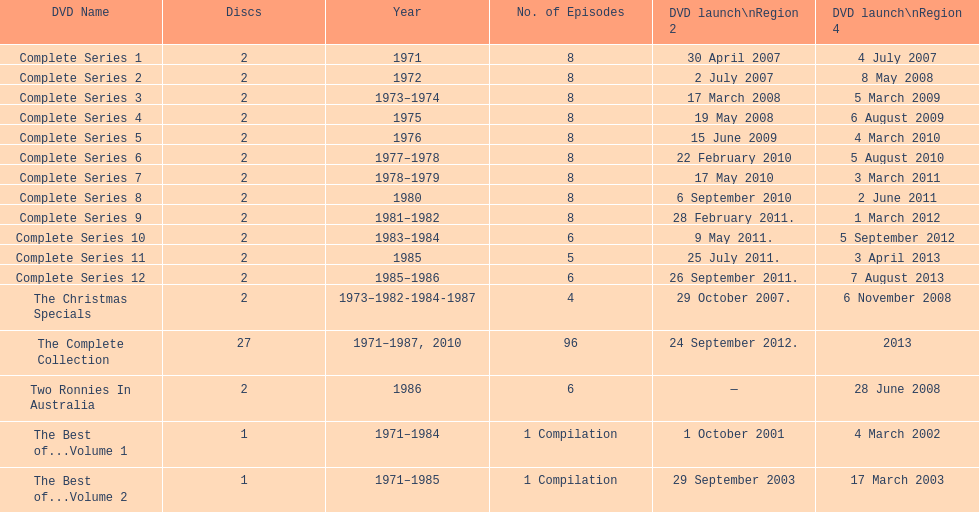Total number of episodes released in region 2 in 2007 20. 